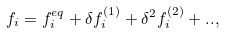Convert formula to latex. <formula><loc_0><loc_0><loc_500><loc_500>f _ { i } = f _ { i } ^ { e q } + \delta f _ { i } ^ { ( 1 ) } + \delta ^ { 2 } f _ { i } ^ { ( 2 ) } + . . ,</formula> 